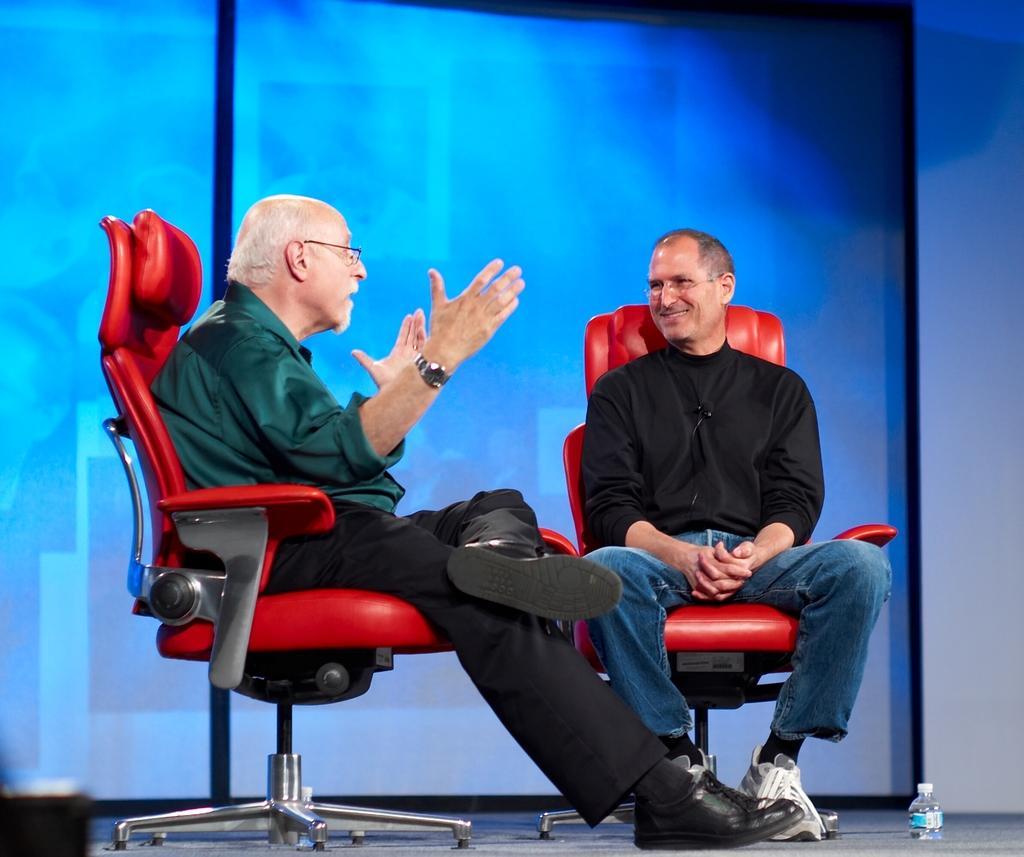How would you summarize this image in a sentence or two? In this image I see 2 men, in which one of them is smiling and both of them are sitting on the chairs and I can also see a bottle over here. 